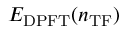Convert formula to latex. <formula><loc_0><loc_0><loc_500><loc_500>E _ { D P F T } ( n _ { T F } )</formula> 